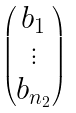<formula> <loc_0><loc_0><loc_500><loc_500>\begin{pmatrix} b _ { 1 } \\ \vdots \\ b _ { n _ { 2 } } \end{pmatrix}</formula> 